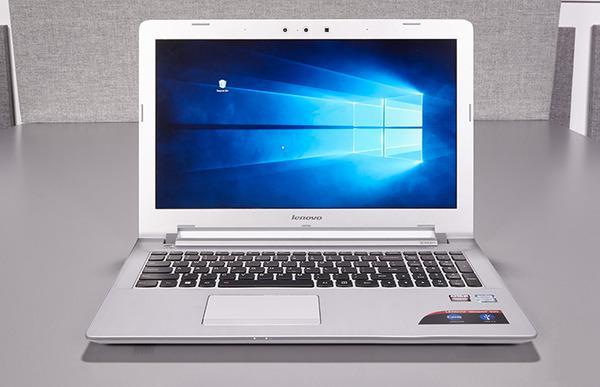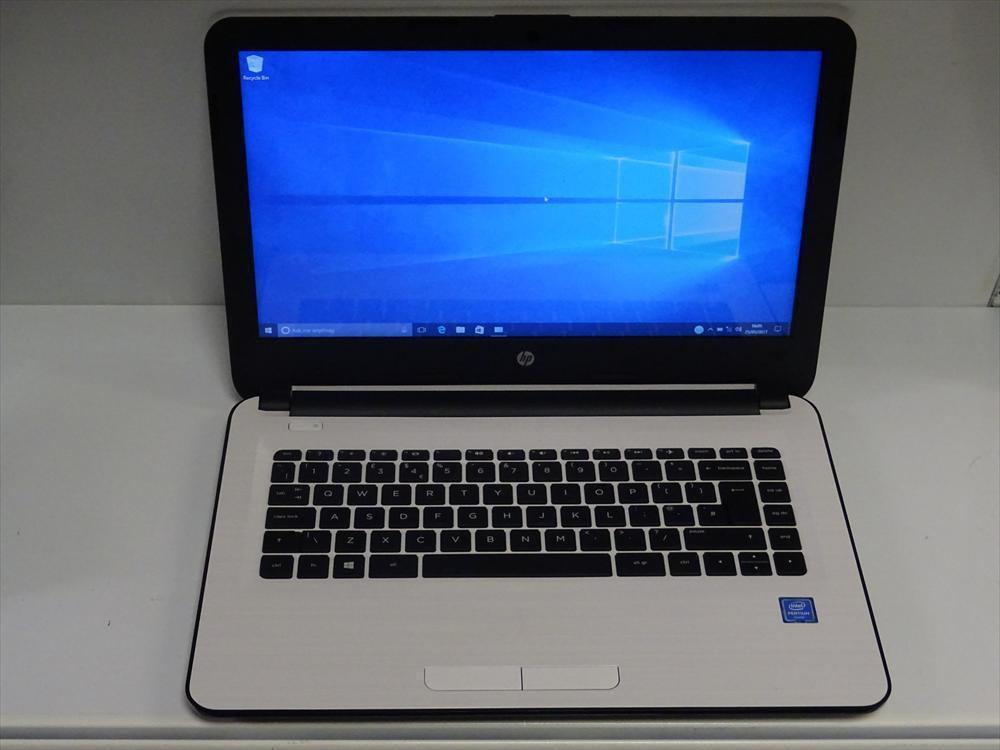The first image is the image on the left, the second image is the image on the right. Evaluate the accuracy of this statement regarding the images: "The laptop on the right has its start menu open and visible.". Is it true? Answer yes or no. No. 